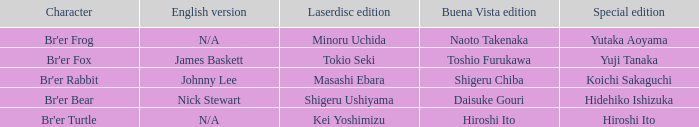What is the english version that is buena vista edition is daisuke gouri? Nick Stewart. 